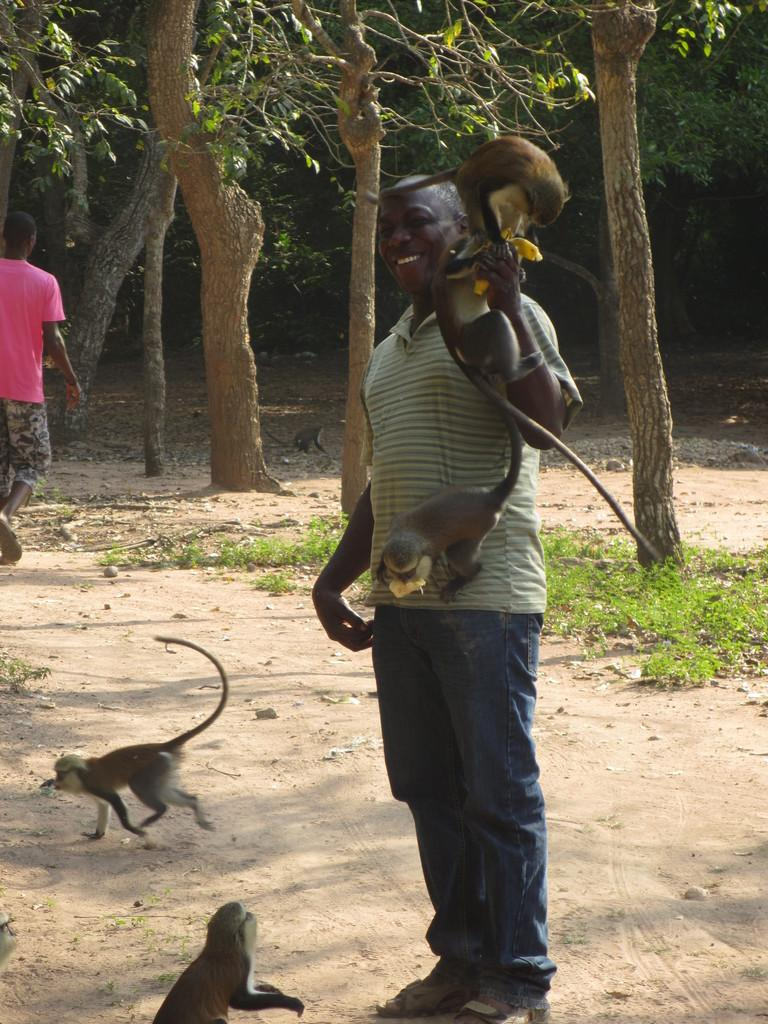What types of living organisms are present in the image? There are animals in the image. Can you describe the other subjects in the image? There is a group of people in the image. What can be seen in the background of the image? There are trees in the background of the image. What type of hydrant is visible in the image? There is no hydrant present in the image. How many knees can be seen in the image? The number of knees cannot be determined from the image, as it only shows a group of people and animals, not individual body parts. 